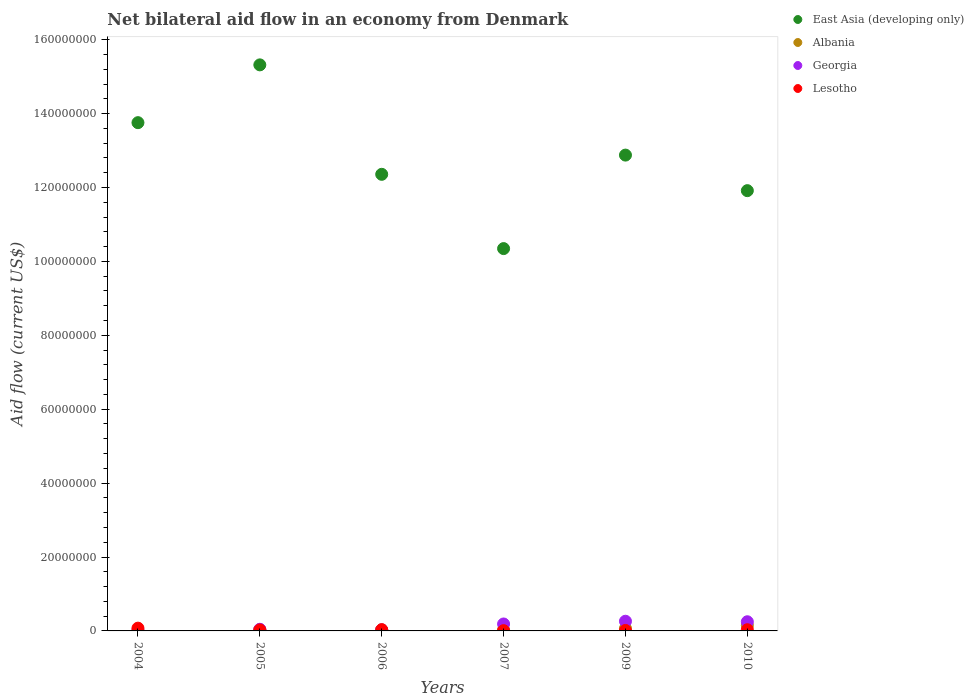What is the net bilateral aid flow in Albania in 2007?
Your answer should be compact. 2.90e+05. Across all years, what is the maximum net bilateral aid flow in Albania?
Your answer should be very brief. 1.49e+06. In which year was the net bilateral aid flow in Georgia minimum?
Provide a succinct answer. 2004. What is the total net bilateral aid flow in East Asia (developing only) in the graph?
Your response must be concise. 7.66e+08. What is the difference between the net bilateral aid flow in Albania in 2004 and that in 2007?
Offer a terse response. -2.60e+05. What is the difference between the net bilateral aid flow in Albania in 2005 and the net bilateral aid flow in Georgia in 2010?
Offer a terse response. -2.13e+06. What is the average net bilateral aid flow in East Asia (developing only) per year?
Provide a short and direct response. 1.28e+08. In the year 2004, what is the difference between the net bilateral aid flow in East Asia (developing only) and net bilateral aid flow in Lesotho?
Give a very brief answer. 1.37e+08. In how many years, is the net bilateral aid flow in East Asia (developing only) greater than 56000000 US$?
Provide a short and direct response. 6. What is the ratio of the net bilateral aid flow in Lesotho in 2006 to that in 2010?
Ensure brevity in your answer.  1.06. Is the net bilateral aid flow in Lesotho in 2004 less than that in 2007?
Make the answer very short. No. Is the difference between the net bilateral aid flow in East Asia (developing only) in 2006 and 2010 greater than the difference between the net bilateral aid flow in Lesotho in 2006 and 2010?
Give a very brief answer. Yes. What is the difference between the highest and the second highest net bilateral aid flow in Albania?
Your answer should be very brief. 8.10e+05. What is the difference between the highest and the lowest net bilateral aid flow in Albania?
Make the answer very short. 1.46e+06. In how many years, is the net bilateral aid flow in Lesotho greater than the average net bilateral aid flow in Lesotho taken over all years?
Give a very brief answer. 3. Is the sum of the net bilateral aid flow in Georgia in 2004 and 2007 greater than the maximum net bilateral aid flow in Lesotho across all years?
Your answer should be very brief. Yes. Is it the case that in every year, the sum of the net bilateral aid flow in East Asia (developing only) and net bilateral aid flow in Georgia  is greater than the net bilateral aid flow in Albania?
Provide a succinct answer. Yes. Is the net bilateral aid flow in Georgia strictly greater than the net bilateral aid flow in East Asia (developing only) over the years?
Ensure brevity in your answer.  No. How many years are there in the graph?
Make the answer very short. 6. Are the values on the major ticks of Y-axis written in scientific E-notation?
Your answer should be very brief. No. Does the graph contain any zero values?
Your answer should be very brief. No. Does the graph contain grids?
Provide a succinct answer. No. Where does the legend appear in the graph?
Your answer should be compact. Top right. How many legend labels are there?
Ensure brevity in your answer.  4. What is the title of the graph?
Make the answer very short. Net bilateral aid flow in an economy from Denmark. Does "Azerbaijan" appear as one of the legend labels in the graph?
Give a very brief answer. No. What is the label or title of the X-axis?
Provide a succinct answer. Years. What is the label or title of the Y-axis?
Your answer should be compact. Aid flow (current US$). What is the Aid flow (current US$) of East Asia (developing only) in 2004?
Your answer should be very brief. 1.38e+08. What is the Aid flow (current US$) of Lesotho in 2004?
Ensure brevity in your answer.  7.50e+05. What is the Aid flow (current US$) of East Asia (developing only) in 2005?
Your answer should be compact. 1.53e+08. What is the Aid flow (current US$) of Albania in 2005?
Provide a short and direct response. 3.50e+05. What is the Aid flow (current US$) in Lesotho in 2005?
Your answer should be compact. 2.70e+05. What is the Aid flow (current US$) of East Asia (developing only) in 2006?
Keep it short and to the point. 1.24e+08. What is the Aid flow (current US$) in Albania in 2006?
Keep it short and to the point. 2.60e+05. What is the Aid flow (current US$) of Georgia in 2006?
Offer a very short reply. 2.80e+05. What is the Aid flow (current US$) of Lesotho in 2006?
Your answer should be very brief. 3.40e+05. What is the Aid flow (current US$) in East Asia (developing only) in 2007?
Provide a succinct answer. 1.03e+08. What is the Aid flow (current US$) of Albania in 2007?
Offer a terse response. 2.90e+05. What is the Aid flow (current US$) of Georgia in 2007?
Your answer should be compact. 1.88e+06. What is the Aid flow (current US$) of East Asia (developing only) in 2009?
Ensure brevity in your answer.  1.29e+08. What is the Aid flow (current US$) of Albania in 2009?
Your answer should be compact. 6.80e+05. What is the Aid flow (current US$) in Georgia in 2009?
Your answer should be very brief. 2.62e+06. What is the Aid flow (current US$) in Lesotho in 2009?
Provide a succinct answer. 1.30e+05. What is the Aid flow (current US$) in East Asia (developing only) in 2010?
Offer a terse response. 1.19e+08. What is the Aid flow (current US$) of Albania in 2010?
Make the answer very short. 1.49e+06. What is the Aid flow (current US$) of Georgia in 2010?
Keep it short and to the point. 2.48e+06. What is the Aid flow (current US$) in Lesotho in 2010?
Your answer should be very brief. 3.20e+05. Across all years, what is the maximum Aid flow (current US$) of East Asia (developing only)?
Ensure brevity in your answer.  1.53e+08. Across all years, what is the maximum Aid flow (current US$) of Albania?
Offer a terse response. 1.49e+06. Across all years, what is the maximum Aid flow (current US$) in Georgia?
Your answer should be compact. 2.62e+06. Across all years, what is the maximum Aid flow (current US$) in Lesotho?
Your answer should be very brief. 7.50e+05. Across all years, what is the minimum Aid flow (current US$) in East Asia (developing only)?
Offer a very short reply. 1.03e+08. Across all years, what is the minimum Aid flow (current US$) of Georgia?
Your answer should be very brief. 1.50e+05. What is the total Aid flow (current US$) of East Asia (developing only) in the graph?
Offer a terse response. 7.66e+08. What is the total Aid flow (current US$) in Albania in the graph?
Keep it short and to the point. 3.10e+06. What is the total Aid flow (current US$) in Georgia in the graph?
Ensure brevity in your answer.  7.85e+06. What is the total Aid flow (current US$) in Lesotho in the graph?
Offer a terse response. 1.88e+06. What is the difference between the Aid flow (current US$) in East Asia (developing only) in 2004 and that in 2005?
Ensure brevity in your answer.  -1.56e+07. What is the difference between the Aid flow (current US$) in Albania in 2004 and that in 2005?
Your response must be concise. -3.20e+05. What is the difference between the Aid flow (current US$) in Georgia in 2004 and that in 2005?
Offer a terse response. -2.90e+05. What is the difference between the Aid flow (current US$) of Lesotho in 2004 and that in 2005?
Give a very brief answer. 4.80e+05. What is the difference between the Aid flow (current US$) in East Asia (developing only) in 2004 and that in 2006?
Give a very brief answer. 1.40e+07. What is the difference between the Aid flow (current US$) of East Asia (developing only) in 2004 and that in 2007?
Your answer should be compact. 3.41e+07. What is the difference between the Aid flow (current US$) in Albania in 2004 and that in 2007?
Offer a terse response. -2.60e+05. What is the difference between the Aid flow (current US$) of Georgia in 2004 and that in 2007?
Provide a short and direct response. -1.73e+06. What is the difference between the Aid flow (current US$) in Lesotho in 2004 and that in 2007?
Offer a terse response. 6.80e+05. What is the difference between the Aid flow (current US$) in East Asia (developing only) in 2004 and that in 2009?
Provide a succinct answer. 8.78e+06. What is the difference between the Aid flow (current US$) of Albania in 2004 and that in 2009?
Keep it short and to the point. -6.50e+05. What is the difference between the Aid flow (current US$) in Georgia in 2004 and that in 2009?
Your answer should be very brief. -2.47e+06. What is the difference between the Aid flow (current US$) in Lesotho in 2004 and that in 2009?
Your answer should be compact. 6.20e+05. What is the difference between the Aid flow (current US$) of East Asia (developing only) in 2004 and that in 2010?
Your response must be concise. 1.84e+07. What is the difference between the Aid flow (current US$) in Albania in 2004 and that in 2010?
Your answer should be very brief. -1.46e+06. What is the difference between the Aid flow (current US$) in Georgia in 2004 and that in 2010?
Give a very brief answer. -2.33e+06. What is the difference between the Aid flow (current US$) of East Asia (developing only) in 2005 and that in 2006?
Ensure brevity in your answer.  2.96e+07. What is the difference between the Aid flow (current US$) in Albania in 2005 and that in 2006?
Give a very brief answer. 9.00e+04. What is the difference between the Aid flow (current US$) in East Asia (developing only) in 2005 and that in 2007?
Offer a terse response. 4.97e+07. What is the difference between the Aid flow (current US$) in Albania in 2005 and that in 2007?
Your response must be concise. 6.00e+04. What is the difference between the Aid flow (current US$) in Georgia in 2005 and that in 2007?
Your answer should be very brief. -1.44e+06. What is the difference between the Aid flow (current US$) of East Asia (developing only) in 2005 and that in 2009?
Your answer should be very brief. 2.44e+07. What is the difference between the Aid flow (current US$) in Albania in 2005 and that in 2009?
Provide a succinct answer. -3.30e+05. What is the difference between the Aid flow (current US$) of Georgia in 2005 and that in 2009?
Provide a short and direct response. -2.18e+06. What is the difference between the Aid flow (current US$) of Lesotho in 2005 and that in 2009?
Give a very brief answer. 1.40e+05. What is the difference between the Aid flow (current US$) in East Asia (developing only) in 2005 and that in 2010?
Offer a very short reply. 3.40e+07. What is the difference between the Aid flow (current US$) in Albania in 2005 and that in 2010?
Your answer should be very brief. -1.14e+06. What is the difference between the Aid flow (current US$) in Georgia in 2005 and that in 2010?
Your answer should be very brief. -2.04e+06. What is the difference between the Aid flow (current US$) of East Asia (developing only) in 2006 and that in 2007?
Provide a short and direct response. 2.01e+07. What is the difference between the Aid flow (current US$) of Albania in 2006 and that in 2007?
Offer a very short reply. -3.00e+04. What is the difference between the Aid flow (current US$) in Georgia in 2006 and that in 2007?
Offer a terse response. -1.60e+06. What is the difference between the Aid flow (current US$) in Lesotho in 2006 and that in 2007?
Ensure brevity in your answer.  2.70e+05. What is the difference between the Aid flow (current US$) in East Asia (developing only) in 2006 and that in 2009?
Your answer should be very brief. -5.20e+06. What is the difference between the Aid flow (current US$) of Albania in 2006 and that in 2009?
Your response must be concise. -4.20e+05. What is the difference between the Aid flow (current US$) of Georgia in 2006 and that in 2009?
Offer a very short reply. -2.34e+06. What is the difference between the Aid flow (current US$) in East Asia (developing only) in 2006 and that in 2010?
Provide a succinct answer. 4.42e+06. What is the difference between the Aid flow (current US$) in Albania in 2006 and that in 2010?
Provide a short and direct response. -1.23e+06. What is the difference between the Aid flow (current US$) of Georgia in 2006 and that in 2010?
Your response must be concise. -2.20e+06. What is the difference between the Aid flow (current US$) in East Asia (developing only) in 2007 and that in 2009?
Offer a very short reply. -2.53e+07. What is the difference between the Aid flow (current US$) in Albania in 2007 and that in 2009?
Provide a succinct answer. -3.90e+05. What is the difference between the Aid flow (current US$) in Georgia in 2007 and that in 2009?
Provide a short and direct response. -7.40e+05. What is the difference between the Aid flow (current US$) of Lesotho in 2007 and that in 2009?
Provide a short and direct response. -6.00e+04. What is the difference between the Aid flow (current US$) in East Asia (developing only) in 2007 and that in 2010?
Make the answer very short. -1.57e+07. What is the difference between the Aid flow (current US$) of Albania in 2007 and that in 2010?
Make the answer very short. -1.20e+06. What is the difference between the Aid flow (current US$) in Georgia in 2007 and that in 2010?
Offer a very short reply. -6.00e+05. What is the difference between the Aid flow (current US$) of East Asia (developing only) in 2009 and that in 2010?
Your answer should be compact. 9.62e+06. What is the difference between the Aid flow (current US$) of Albania in 2009 and that in 2010?
Offer a very short reply. -8.10e+05. What is the difference between the Aid flow (current US$) of Georgia in 2009 and that in 2010?
Keep it short and to the point. 1.40e+05. What is the difference between the Aid flow (current US$) of East Asia (developing only) in 2004 and the Aid flow (current US$) of Albania in 2005?
Offer a terse response. 1.37e+08. What is the difference between the Aid flow (current US$) of East Asia (developing only) in 2004 and the Aid flow (current US$) of Georgia in 2005?
Your answer should be very brief. 1.37e+08. What is the difference between the Aid flow (current US$) in East Asia (developing only) in 2004 and the Aid flow (current US$) in Lesotho in 2005?
Your answer should be compact. 1.37e+08. What is the difference between the Aid flow (current US$) in Albania in 2004 and the Aid flow (current US$) in Georgia in 2005?
Make the answer very short. -4.10e+05. What is the difference between the Aid flow (current US$) of Albania in 2004 and the Aid flow (current US$) of Lesotho in 2005?
Your answer should be compact. -2.40e+05. What is the difference between the Aid flow (current US$) of Georgia in 2004 and the Aid flow (current US$) of Lesotho in 2005?
Give a very brief answer. -1.20e+05. What is the difference between the Aid flow (current US$) in East Asia (developing only) in 2004 and the Aid flow (current US$) in Albania in 2006?
Offer a very short reply. 1.37e+08. What is the difference between the Aid flow (current US$) of East Asia (developing only) in 2004 and the Aid flow (current US$) of Georgia in 2006?
Ensure brevity in your answer.  1.37e+08. What is the difference between the Aid flow (current US$) of East Asia (developing only) in 2004 and the Aid flow (current US$) of Lesotho in 2006?
Your response must be concise. 1.37e+08. What is the difference between the Aid flow (current US$) of Albania in 2004 and the Aid flow (current US$) of Lesotho in 2006?
Provide a short and direct response. -3.10e+05. What is the difference between the Aid flow (current US$) in Georgia in 2004 and the Aid flow (current US$) in Lesotho in 2006?
Offer a terse response. -1.90e+05. What is the difference between the Aid flow (current US$) in East Asia (developing only) in 2004 and the Aid flow (current US$) in Albania in 2007?
Provide a short and direct response. 1.37e+08. What is the difference between the Aid flow (current US$) in East Asia (developing only) in 2004 and the Aid flow (current US$) in Georgia in 2007?
Provide a short and direct response. 1.36e+08. What is the difference between the Aid flow (current US$) of East Asia (developing only) in 2004 and the Aid flow (current US$) of Lesotho in 2007?
Your answer should be compact. 1.37e+08. What is the difference between the Aid flow (current US$) in Albania in 2004 and the Aid flow (current US$) in Georgia in 2007?
Provide a succinct answer. -1.85e+06. What is the difference between the Aid flow (current US$) of Albania in 2004 and the Aid flow (current US$) of Lesotho in 2007?
Offer a terse response. -4.00e+04. What is the difference between the Aid flow (current US$) in East Asia (developing only) in 2004 and the Aid flow (current US$) in Albania in 2009?
Offer a terse response. 1.37e+08. What is the difference between the Aid flow (current US$) of East Asia (developing only) in 2004 and the Aid flow (current US$) of Georgia in 2009?
Offer a terse response. 1.35e+08. What is the difference between the Aid flow (current US$) of East Asia (developing only) in 2004 and the Aid flow (current US$) of Lesotho in 2009?
Give a very brief answer. 1.37e+08. What is the difference between the Aid flow (current US$) in Albania in 2004 and the Aid flow (current US$) in Georgia in 2009?
Offer a very short reply. -2.59e+06. What is the difference between the Aid flow (current US$) of Georgia in 2004 and the Aid flow (current US$) of Lesotho in 2009?
Make the answer very short. 2.00e+04. What is the difference between the Aid flow (current US$) in East Asia (developing only) in 2004 and the Aid flow (current US$) in Albania in 2010?
Keep it short and to the point. 1.36e+08. What is the difference between the Aid flow (current US$) of East Asia (developing only) in 2004 and the Aid flow (current US$) of Georgia in 2010?
Provide a succinct answer. 1.35e+08. What is the difference between the Aid flow (current US$) in East Asia (developing only) in 2004 and the Aid flow (current US$) in Lesotho in 2010?
Make the answer very short. 1.37e+08. What is the difference between the Aid flow (current US$) in Albania in 2004 and the Aid flow (current US$) in Georgia in 2010?
Give a very brief answer. -2.45e+06. What is the difference between the Aid flow (current US$) of Georgia in 2004 and the Aid flow (current US$) of Lesotho in 2010?
Offer a terse response. -1.70e+05. What is the difference between the Aid flow (current US$) in East Asia (developing only) in 2005 and the Aid flow (current US$) in Albania in 2006?
Provide a succinct answer. 1.53e+08. What is the difference between the Aid flow (current US$) in East Asia (developing only) in 2005 and the Aid flow (current US$) in Georgia in 2006?
Offer a very short reply. 1.53e+08. What is the difference between the Aid flow (current US$) of East Asia (developing only) in 2005 and the Aid flow (current US$) of Lesotho in 2006?
Your answer should be very brief. 1.53e+08. What is the difference between the Aid flow (current US$) of Albania in 2005 and the Aid flow (current US$) of Georgia in 2006?
Your answer should be very brief. 7.00e+04. What is the difference between the Aid flow (current US$) of East Asia (developing only) in 2005 and the Aid flow (current US$) of Albania in 2007?
Your answer should be compact. 1.53e+08. What is the difference between the Aid flow (current US$) of East Asia (developing only) in 2005 and the Aid flow (current US$) of Georgia in 2007?
Provide a short and direct response. 1.51e+08. What is the difference between the Aid flow (current US$) of East Asia (developing only) in 2005 and the Aid flow (current US$) of Lesotho in 2007?
Your answer should be compact. 1.53e+08. What is the difference between the Aid flow (current US$) in Albania in 2005 and the Aid flow (current US$) in Georgia in 2007?
Provide a short and direct response. -1.53e+06. What is the difference between the Aid flow (current US$) in Albania in 2005 and the Aid flow (current US$) in Lesotho in 2007?
Give a very brief answer. 2.80e+05. What is the difference between the Aid flow (current US$) in East Asia (developing only) in 2005 and the Aid flow (current US$) in Albania in 2009?
Your answer should be compact. 1.53e+08. What is the difference between the Aid flow (current US$) of East Asia (developing only) in 2005 and the Aid flow (current US$) of Georgia in 2009?
Ensure brevity in your answer.  1.51e+08. What is the difference between the Aid flow (current US$) of East Asia (developing only) in 2005 and the Aid flow (current US$) of Lesotho in 2009?
Your answer should be very brief. 1.53e+08. What is the difference between the Aid flow (current US$) of Albania in 2005 and the Aid flow (current US$) of Georgia in 2009?
Ensure brevity in your answer.  -2.27e+06. What is the difference between the Aid flow (current US$) in Albania in 2005 and the Aid flow (current US$) in Lesotho in 2009?
Make the answer very short. 2.20e+05. What is the difference between the Aid flow (current US$) in East Asia (developing only) in 2005 and the Aid flow (current US$) in Albania in 2010?
Your response must be concise. 1.52e+08. What is the difference between the Aid flow (current US$) of East Asia (developing only) in 2005 and the Aid flow (current US$) of Georgia in 2010?
Your answer should be very brief. 1.51e+08. What is the difference between the Aid flow (current US$) of East Asia (developing only) in 2005 and the Aid flow (current US$) of Lesotho in 2010?
Make the answer very short. 1.53e+08. What is the difference between the Aid flow (current US$) of Albania in 2005 and the Aid flow (current US$) of Georgia in 2010?
Give a very brief answer. -2.13e+06. What is the difference between the Aid flow (current US$) of Albania in 2005 and the Aid flow (current US$) of Lesotho in 2010?
Make the answer very short. 3.00e+04. What is the difference between the Aid flow (current US$) in Georgia in 2005 and the Aid flow (current US$) in Lesotho in 2010?
Offer a very short reply. 1.20e+05. What is the difference between the Aid flow (current US$) in East Asia (developing only) in 2006 and the Aid flow (current US$) in Albania in 2007?
Give a very brief answer. 1.23e+08. What is the difference between the Aid flow (current US$) in East Asia (developing only) in 2006 and the Aid flow (current US$) in Georgia in 2007?
Ensure brevity in your answer.  1.22e+08. What is the difference between the Aid flow (current US$) in East Asia (developing only) in 2006 and the Aid flow (current US$) in Lesotho in 2007?
Offer a terse response. 1.24e+08. What is the difference between the Aid flow (current US$) of Albania in 2006 and the Aid flow (current US$) of Georgia in 2007?
Your response must be concise. -1.62e+06. What is the difference between the Aid flow (current US$) of East Asia (developing only) in 2006 and the Aid flow (current US$) of Albania in 2009?
Give a very brief answer. 1.23e+08. What is the difference between the Aid flow (current US$) of East Asia (developing only) in 2006 and the Aid flow (current US$) of Georgia in 2009?
Your response must be concise. 1.21e+08. What is the difference between the Aid flow (current US$) in East Asia (developing only) in 2006 and the Aid flow (current US$) in Lesotho in 2009?
Provide a short and direct response. 1.23e+08. What is the difference between the Aid flow (current US$) in Albania in 2006 and the Aid flow (current US$) in Georgia in 2009?
Give a very brief answer. -2.36e+06. What is the difference between the Aid flow (current US$) of Albania in 2006 and the Aid flow (current US$) of Lesotho in 2009?
Ensure brevity in your answer.  1.30e+05. What is the difference between the Aid flow (current US$) of East Asia (developing only) in 2006 and the Aid flow (current US$) of Albania in 2010?
Give a very brief answer. 1.22e+08. What is the difference between the Aid flow (current US$) of East Asia (developing only) in 2006 and the Aid flow (current US$) of Georgia in 2010?
Keep it short and to the point. 1.21e+08. What is the difference between the Aid flow (current US$) of East Asia (developing only) in 2006 and the Aid flow (current US$) of Lesotho in 2010?
Give a very brief answer. 1.23e+08. What is the difference between the Aid flow (current US$) in Albania in 2006 and the Aid flow (current US$) in Georgia in 2010?
Your answer should be very brief. -2.22e+06. What is the difference between the Aid flow (current US$) of Georgia in 2006 and the Aid flow (current US$) of Lesotho in 2010?
Offer a very short reply. -4.00e+04. What is the difference between the Aid flow (current US$) of East Asia (developing only) in 2007 and the Aid flow (current US$) of Albania in 2009?
Your response must be concise. 1.03e+08. What is the difference between the Aid flow (current US$) of East Asia (developing only) in 2007 and the Aid flow (current US$) of Georgia in 2009?
Ensure brevity in your answer.  1.01e+08. What is the difference between the Aid flow (current US$) of East Asia (developing only) in 2007 and the Aid flow (current US$) of Lesotho in 2009?
Provide a succinct answer. 1.03e+08. What is the difference between the Aid flow (current US$) of Albania in 2007 and the Aid flow (current US$) of Georgia in 2009?
Your answer should be compact. -2.33e+06. What is the difference between the Aid flow (current US$) in Georgia in 2007 and the Aid flow (current US$) in Lesotho in 2009?
Keep it short and to the point. 1.75e+06. What is the difference between the Aid flow (current US$) in East Asia (developing only) in 2007 and the Aid flow (current US$) in Albania in 2010?
Ensure brevity in your answer.  1.02e+08. What is the difference between the Aid flow (current US$) of East Asia (developing only) in 2007 and the Aid flow (current US$) of Georgia in 2010?
Provide a succinct answer. 1.01e+08. What is the difference between the Aid flow (current US$) of East Asia (developing only) in 2007 and the Aid flow (current US$) of Lesotho in 2010?
Your answer should be very brief. 1.03e+08. What is the difference between the Aid flow (current US$) of Albania in 2007 and the Aid flow (current US$) of Georgia in 2010?
Your answer should be very brief. -2.19e+06. What is the difference between the Aid flow (current US$) in Georgia in 2007 and the Aid flow (current US$) in Lesotho in 2010?
Make the answer very short. 1.56e+06. What is the difference between the Aid flow (current US$) in East Asia (developing only) in 2009 and the Aid flow (current US$) in Albania in 2010?
Ensure brevity in your answer.  1.27e+08. What is the difference between the Aid flow (current US$) in East Asia (developing only) in 2009 and the Aid flow (current US$) in Georgia in 2010?
Your response must be concise. 1.26e+08. What is the difference between the Aid flow (current US$) of East Asia (developing only) in 2009 and the Aid flow (current US$) of Lesotho in 2010?
Ensure brevity in your answer.  1.28e+08. What is the difference between the Aid flow (current US$) of Albania in 2009 and the Aid flow (current US$) of Georgia in 2010?
Your answer should be very brief. -1.80e+06. What is the difference between the Aid flow (current US$) of Georgia in 2009 and the Aid flow (current US$) of Lesotho in 2010?
Give a very brief answer. 2.30e+06. What is the average Aid flow (current US$) in East Asia (developing only) per year?
Ensure brevity in your answer.  1.28e+08. What is the average Aid flow (current US$) of Albania per year?
Offer a very short reply. 5.17e+05. What is the average Aid flow (current US$) of Georgia per year?
Make the answer very short. 1.31e+06. What is the average Aid flow (current US$) of Lesotho per year?
Your answer should be very brief. 3.13e+05. In the year 2004, what is the difference between the Aid flow (current US$) of East Asia (developing only) and Aid flow (current US$) of Albania?
Your answer should be very brief. 1.38e+08. In the year 2004, what is the difference between the Aid flow (current US$) of East Asia (developing only) and Aid flow (current US$) of Georgia?
Your answer should be compact. 1.37e+08. In the year 2004, what is the difference between the Aid flow (current US$) of East Asia (developing only) and Aid flow (current US$) of Lesotho?
Your response must be concise. 1.37e+08. In the year 2004, what is the difference between the Aid flow (current US$) in Albania and Aid flow (current US$) in Georgia?
Your response must be concise. -1.20e+05. In the year 2004, what is the difference between the Aid flow (current US$) of Albania and Aid flow (current US$) of Lesotho?
Give a very brief answer. -7.20e+05. In the year 2004, what is the difference between the Aid flow (current US$) in Georgia and Aid flow (current US$) in Lesotho?
Offer a terse response. -6.00e+05. In the year 2005, what is the difference between the Aid flow (current US$) in East Asia (developing only) and Aid flow (current US$) in Albania?
Ensure brevity in your answer.  1.53e+08. In the year 2005, what is the difference between the Aid flow (current US$) of East Asia (developing only) and Aid flow (current US$) of Georgia?
Your response must be concise. 1.53e+08. In the year 2005, what is the difference between the Aid flow (current US$) in East Asia (developing only) and Aid flow (current US$) in Lesotho?
Offer a very short reply. 1.53e+08. In the year 2005, what is the difference between the Aid flow (current US$) in Albania and Aid flow (current US$) in Georgia?
Your response must be concise. -9.00e+04. In the year 2005, what is the difference between the Aid flow (current US$) in Albania and Aid flow (current US$) in Lesotho?
Make the answer very short. 8.00e+04. In the year 2006, what is the difference between the Aid flow (current US$) of East Asia (developing only) and Aid flow (current US$) of Albania?
Your answer should be very brief. 1.23e+08. In the year 2006, what is the difference between the Aid flow (current US$) of East Asia (developing only) and Aid flow (current US$) of Georgia?
Give a very brief answer. 1.23e+08. In the year 2006, what is the difference between the Aid flow (current US$) in East Asia (developing only) and Aid flow (current US$) in Lesotho?
Offer a very short reply. 1.23e+08. In the year 2006, what is the difference between the Aid flow (current US$) of Albania and Aid flow (current US$) of Georgia?
Your response must be concise. -2.00e+04. In the year 2006, what is the difference between the Aid flow (current US$) of Albania and Aid flow (current US$) of Lesotho?
Ensure brevity in your answer.  -8.00e+04. In the year 2006, what is the difference between the Aid flow (current US$) in Georgia and Aid flow (current US$) in Lesotho?
Your response must be concise. -6.00e+04. In the year 2007, what is the difference between the Aid flow (current US$) of East Asia (developing only) and Aid flow (current US$) of Albania?
Keep it short and to the point. 1.03e+08. In the year 2007, what is the difference between the Aid flow (current US$) in East Asia (developing only) and Aid flow (current US$) in Georgia?
Offer a very short reply. 1.02e+08. In the year 2007, what is the difference between the Aid flow (current US$) of East Asia (developing only) and Aid flow (current US$) of Lesotho?
Give a very brief answer. 1.03e+08. In the year 2007, what is the difference between the Aid flow (current US$) in Albania and Aid flow (current US$) in Georgia?
Keep it short and to the point. -1.59e+06. In the year 2007, what is the difference between the Aid flow (current US$) in Georgia and Aid flow (current US$) in Lesotho?
Provide a succinct answer. 1.81e+06. In the year 2009, what is the difference between the Aid flow (current US$) in East Asia (developing only) and Aid flow (current US$) in Albania?
Offer a terse response. 1.28e+08. In the year 2009, what is the difference between the Aid flow (current US$) of East Asia (developing only) and Aid flow (current US$) of Georgia?
Your answer should be very brief. 1.26e+08. In the year 2009, what is the difference between the Aid flow (current US$) of East Asia (developing only) and Aid flow (current US$) of Lesotho?
Make the answer very short. 1.29e+08. In the year 2009, what is the difference between the Aid flow (current US$) in Albania and Aid flow (current US$) in Georgia?
Keep it short and to the point. -1.94e+06. In the year 2009, what is the difference between the Aid flow (current US$) in Georgia and Aid flow (current US$) in Lesotho?
Keep it short and to the point. 2.49e+06. In the year 2010, what is the difference between the Aid flow (current US$) of East Asia (developing only) and Aid flow (current US$) of Albania?
Give a very brief answer. 1.18e+08. In the year 2010, what is the difference between the Aid flow (current US$) in East Asia (developing only) and Aid flow (current US$) in Georgia?
Your answer should be compact. 1.17e+08. In the year 2010, what is the difference between the Aid flow (current US$) in East Asia (developing only) and Aid flow (current US$) in Lesotho?
Your answer should be compact. 1.19e+08. In the year 2010, what is the difference between the Aid flow (current US$) of Albania and Aid flow (current US$) of Georgia?
Make the answer very short. -9.90e+05. In the year 2010, what is the difference between the Aid flow (current US$) of Albania and Aid flow (current US$) of Lesotho?
Provide a short and direct response. 1.17e+06. In the year 2010, what is the difference between the Aid flow (current US$) in Georgia and Aid flow (current US$) in Lesotho?
Provide a succinct answer. 2.16e+06. What is the ratio of the Aid flow (current US$) of East Asia (developing only) in 2004 to that in 2005?
Provide a short and direct response. 0.9. What is the ratio of the Aid flow (current US$) in Albania in 2004 to that in 2005?
Offer a very short reply. 0.09. What is the ratio of the Aid flow (current US$) of Georgia in 2004 to that in 2005?
Provide a short and direct response. 0.34. What is the ratio of the Aid flow (current US$) of Lesotho in 2004 to that in 2005?
Provide a succinct answer. 2.78. What is the ratio of the Aid flow (current US$) in East Asia (developing only) in 2004 to that in 2006?
Offer a terse response. 1.11. What is the ratio of the Aid flow (current US$) in Albania in 2004 to that in 2006?
Provide a succinct answer. 0.12. What is the ratio of the Aid flow (current US$) of Georgia in 2004 to that in 2006?
Your response must be concise. 0.54. What is the ratio of the Aid flow (current US$) in Lesotho in 2004 to that in 2006?
Offer a terse response. 2.21. What is the ratio of the Aid flow (current US$) of East Asia (developing only) in 2004 to that in 2007?
Your answer should be compact. 1.33. What is the ratio of the Aid flow (current US$) in Albania in 2004 to that in 2007?
Your response must be concise. 0.1. What is the ratio of the Aid flow (current US$) of Georgia in 2004 to that in 2007?
Provide a short and direct response. 0.08. What is the ratio of the Aid flow (current US$) of Lesotho in 2004 to that in 2007?
Provide a succinct answer. 10.71. What is the ratio of the Aid flow (current US$) in East Asia (developing only) in 2004 to that in 2009?
Keep it short and to the point. 1.07. What is the ratio of the Aid flow (current US$) in Albania in 2004 to that in 2009?
Give a very brief answer. 0.04. What is the ratio of the Aid flow (current US$) in Georgia in 2004 to that in 2009?
Give a very brief answer. 0.06. What is the ratio of the Aid flow (current US$) of Lesotho in 2004 to that in 2009?
Your answer should be very brief. 5.77. What is the ratio of the Aid flow (current US$) of East Asia (developing only) in 2004 to that in 2010?
Keep it short and to the point. 1.15. What is the ratio of the Aid flow (current US$) of Albania in 2004 to that in 2010?
Keep it short and to the point. 0.02. What is the ratio of the Aid flow (current US$) of Georgia in 2004 to that in 2010?
Provide a succinct answer. 0.06. What is the ratio of the Aid flow (current US$) in Lesotho in 2004 to that in 2010?
Make the answer very short. 2.34. What is the ratio of the Aid flow (current US$) of East Asia (developing only) in 2005 to that in 2006?
Provide a succinct answer. 1.24. What is the ratio of the Aid flow (current US$) in Albania in 2005 to that in 2006?
Keep it short and to the point. 1.35. What is the ratio of the Aid flow (current US$) in Georgia in 2005 to that in 2006?
Offer a terse response. 1.57. What is the ratio of the Aid flow (current US$) of Lesotho in 2005 to that in 2006?
Your answer should be compact. 0.79. What is the ratio of the Aid flow (current US$) of East Asia (developing only) in 2005 to that in 2007?
Provide a succinct answer. 1.48. What is the ratio of the Aid flow (current US$) in Albania in 2005 to that in 2007?
Make the answer very short. 1.21. What is the ratio of the Aid flow (current US$) in Georgia in 2005 to that in 2007?
Provide a short and direct response. 0.23. What is the ratio of the Aid flow (current US$) of Lesotho in 2005 to that in 2007?
Your answer should be compact. 3.86. What is the ratio of the Aid flow (current US$) in East Asia (developing only) in 2005 to that in 2009?
Keep it short and to the point. 1.19. What is the ratio of the Aid flow (current US$) of Albania in 2005 to that in 2009?
Your response must be concise. 0.51. What is the ratio of the Aid flow (current US$) in Georgia in 2005 to that in 2009?
Give a very brief answer. 0.17. What is the ratio of the Aid flow (current US$) of Lesotho in 2005 to that in 2009?
Your answer should be very brief. 2.08. What is the ratio of the Aid flow (current US$) of East Asia (developing only) in 2005 to that in 2010?
Provide a short and direct response. 1.29. What is the ratio of the Aid flow (current US$) of Albania in 2005 to that in 2010?
Your answer should be very brief. 0.23. What is the ratio of the Aid flow (current US$) in Georgia in 2005 to that in 2010?
Your answer should be very brief. 0.18. What is the ratio of the Aid flow (current US$) in Lesotho in 2005 to that in 2010?
Offer a very short reply. 0.84. What is the ratio of the Aid flow (current US$) in East Asia (developing only) in 2006 to that in 2007?
Offer a terse response. 1.19. What is the ratio of the Aid flow (current US$) in Albania in 2006 to that in 2007?
Keep it short and to the point. 0.9. What is the ratio of the Aid flow (current US$) of Georgia in 2006 to that in 2007?
Your answer should be very brief. 0.15. What is the ratio of the Aid flow (current US$) of Lesotho in 2006 to that in 2007?
Offer a terse response. 4.86. What is the ratio of the Aid flow (current US$) of East Asia (developing only) in 2006 to that in 2009?
Ensure brevity in your answer.  0.96. What is the ratio of the Aid flow (current US$) in Albania in 2006 to that in 2009?
Give a very brief answer. 0.38. What is the ratio of the Aid flow (current US$) of Georgia in 2006 to that in 2009?
Provide a short and direct response. 0.11. What is the ratio of the Aid flow (current US$) of Lesotho in 2006 to that in 2009?
Keep it short and to the point. 2.62. What is the ratio of the Aid flow (current US$) in East Asia (developing only) in 2006 to that in 2010?
Give a very brief answer. 1.04. What is the ratio of the Aid flow (current US$) of Albania in 2006 to that in 2010?
Keep it short and to the point. 0.17. What is the ratio of the Aid flow (current US$) of Georgia in 2006 to that in 2010?
Your answer should be compact. 0.11. What is the ratio of the Aid flow (current US$) of Lesotho in 2006 to that in 2010?
Your answer should be compact. 1.06. What is the ratio of the Aid flow (current US$) of East Asia (developing only) in 2007 to that in 2009?
Give a very brief answer. 0.8. What is the ratio of the Aid flow (current US$) of Albania in 2007 to that in 2009?
Your answer should be compact. 0.43. What is the ratio of the Aid flow (current US$) in Georgia in 2007 to that in 2009?
Your answer should be compact. 0.72. What is the ratio of the Aid flow (current US$) of Lesotho in 2007 to that in 2009?
Provide a succinct answer. 0.54. What is the ratio of the Aid flow (current US$) of East Asia (developing only) in 2007 to that in 2010?
Offer a very short reply. 0.87. What is the ratio of the Aid flow (current US$) of Albania in 2007 to that in 2010?
Provide a succinct answer. 0.19. What is the ratio of the Aid flow (current US$) of Georgia in 2007 to that in 2010?
Provide a short and direct response. 0.76. What is the ratio of the Aid flow (current US$) in Lesotho in 2007 to that in 2010?
Keep it short and to the point. 0.22. What is the ratio of the Aid flow (current US$) of East Asia (developing only) in 2009 to that in 2010?
Your answer should be compact. 1.08. What is the ratio of the Aid flow (current US$) of Albania in 2009 to that in 2010?
Keep it short and to the point. 0.46. What is the ratio of the Aid flow (current US$) in Georgia in 2009 to that in 2010?
Offer a very short reply. 1.06. What is the ratio of the Aid flow (current US$) of Lesotho in 2009 to that in 2010?
Offer a terse response. 0.41. What is the difference between the highest and the second highest Aid flow (current US$) in East Asia (developing only)?
Offer a very short reply. 1.56e+07. What is the difference between the highest and the second highest Aid flow (current US$) of Albania?
Offer a very short reply. 8.10e+05. What is the difference between the highest and the lowest Aid flow (current US$) of East Asia (developing only)?
Ensure brevity in your answer.  4.97e+07. What is the difference between the highest and the lowest Aid flow (current US$) of Albania?
Your answer should be compact. 1.46e+06. What is the difference between the highest and the lowest Aid flow (current US$) in Georgia?
Keep it short and to the point. 2.47e+06. What is the difference between the highest and the lowest Aid flow (current US$) of Lesotho?
Offer a terse response. 6.80e+05. 